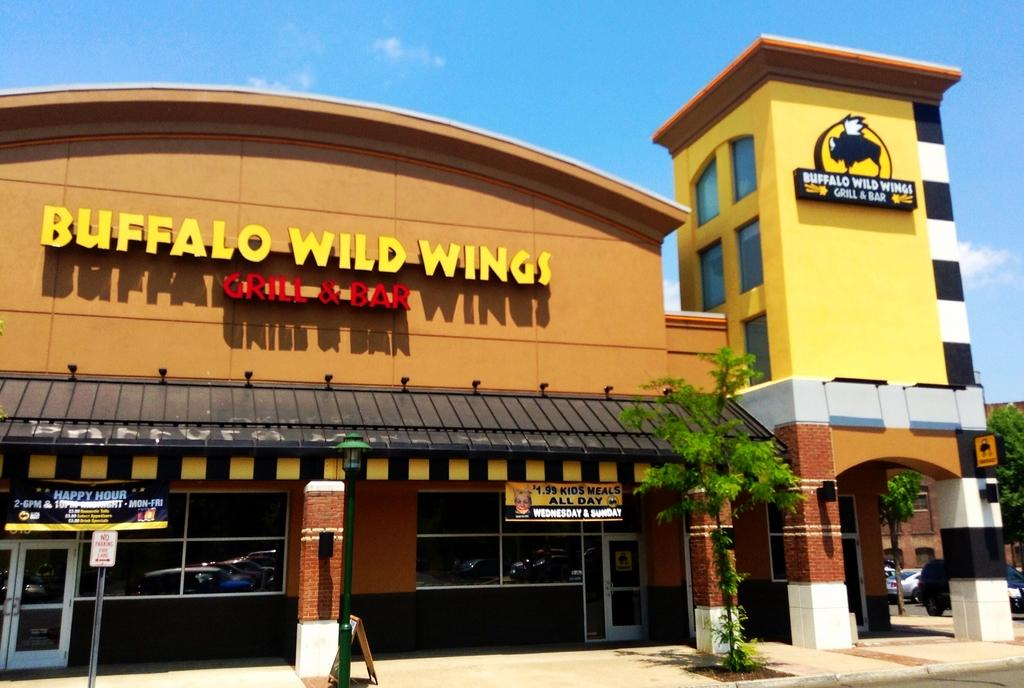What type of vegetation is present in the image? There are plants and trees in the image. What color are the plants and trees? The plants and trees are green. What can be seen in the background of the image? There are stalls in the background of the image. What colors are present on the building in the background? The building in the background has orange and yellow colors. What is the color of the sky in the image? The sky is blue and white. How many chairs are visible in the image? There are no chairs present in the image. What type of clover can be seen growing among the plants in the image? There is no clover present in the image; only plants and trees are visible. 